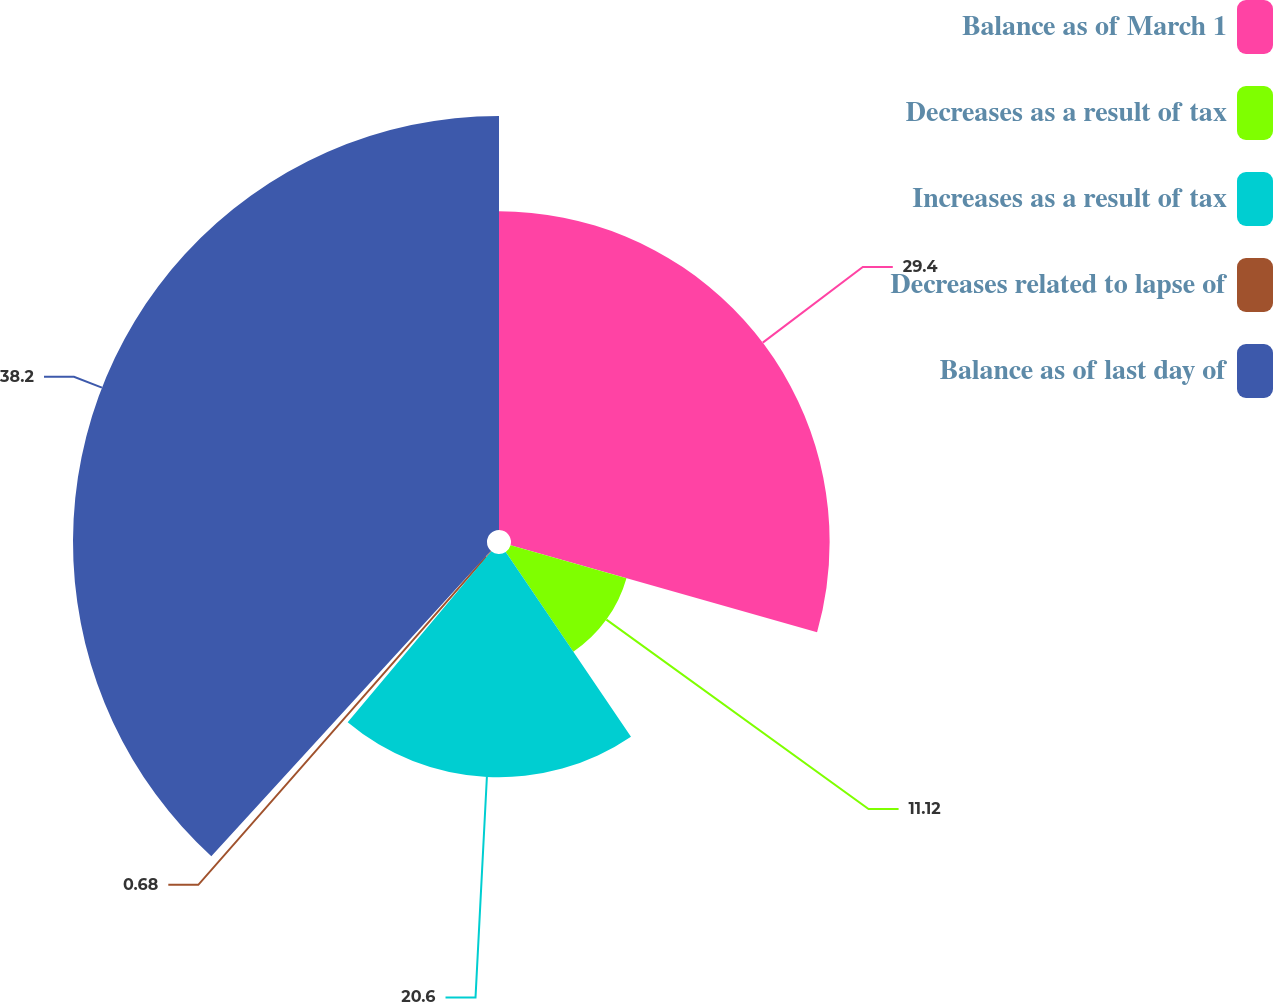<chart> <loc_0><loc_0><loc_500><loc_500><pie_chart><fcel>Balance as of March 1<fcel>Decreases as a result of tax<fcel>Increases as a result of tax<fcel>Decreases related to lapse of<fcel>Balance as of last day of<nl><fcel>29.4%<fcel>11.12%<fcel>20.6%<fcel>0.68%<fcel>38.2%<nl></chart> 